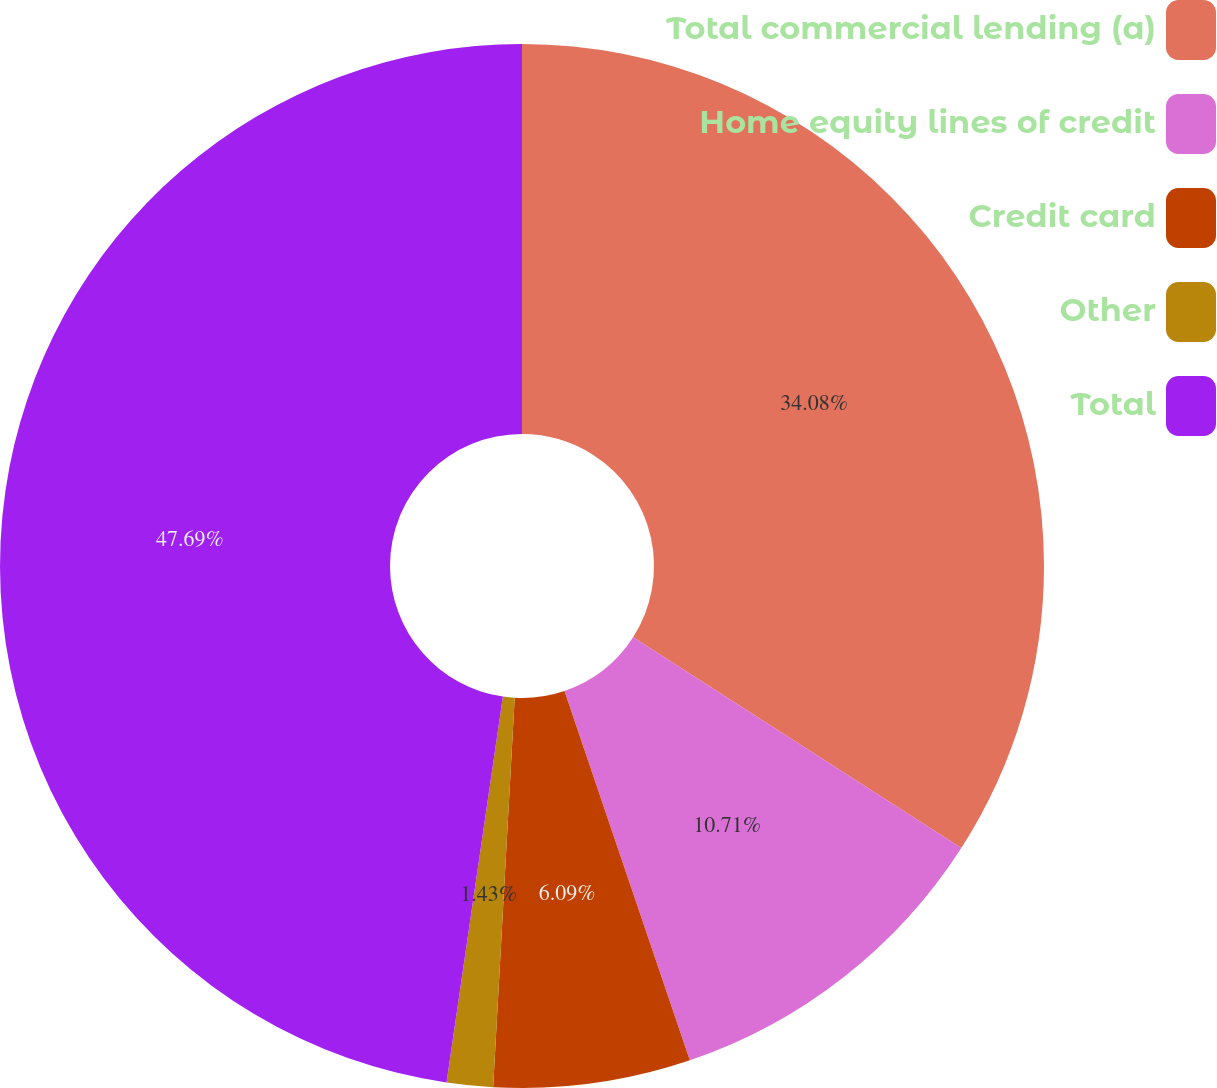Convert chart. <chart><loc_0><loc_0><loc_500><loc_500><pie_chart><fcel>Total commercial lending (a)<fcel>Home equity lines of credit<fcel>Credit card<fcel>Other<fcel>Total<nl><fcel>34.08%<fcel>10.71%<fcel>6.09%<fcel>1.43%<fcel>47.69%<nl></chart> 